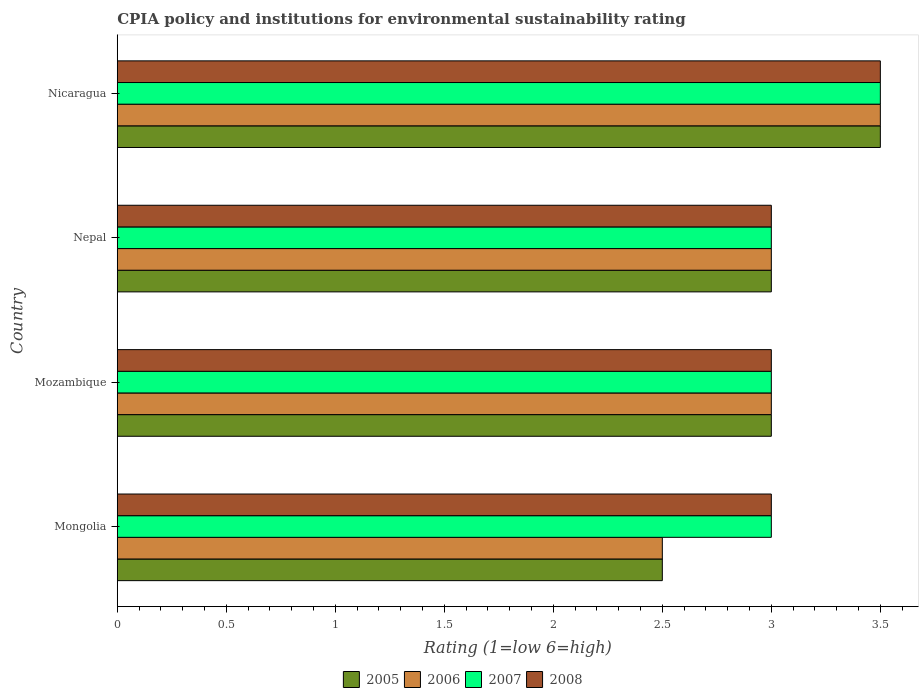How many different coloured bars are there?
Ensure brevity in your answer.  4. Are the number of bars per tick equal to the number of legend labels?
Keep it short and to the point. Yes. How many bars are there on the 3rd tick from the bottom?
Make the answer very short. 4. What is the label of the 2nd group of bars from the top?
Ensure brevity in your answer.  Nepal. In how many cases, is the number of bars for a given country not equal to the number of legend labels?
Provide a short and direct response. 0. What is the CPIA rating in 2007 in Mozambique?
Offer a very short reply. 3. Across all countries, what is the maximum CPIA rating in 2008?
Your response must be concise. 3.5. Across all countries, what is the minimum CPIA rating in 2005?
Your response must be concise. 2.5. In which country was the CPIA rating in 2008 maximum?
Make the answer very short. Nicaragua. In which country was the CPIA rating in 2006 minimum?
Ensure brevity in your answer.  Mongolia. What is the difference between the CPIA rating in 2007 in Mongolia and that in Nepal?
Your response must be concise. 0. What is the average CPIA rating in 2008 per country?
Ensure brevity in your answer.  3.12. What is the difference between the CPIA rating in 2007 and CPIA rating in 2008 in Mongolia?
Offer a very short reply. 0. Is the difference between the CPIA rating in 2007 in Mozambique and Nepal greater than the difference between the CPIA rating in 2008 in Mozambique and Nepal?
Provide a short and direct response. No. What is the difference between the highest and the lowest CPIA rating in 2008?
Make the answer very short. 0.5. In how many countries, is the CPIA rating in 2008 greater than the average CPIA rating in 2008 taken over all countries?
Your answer should be very brief. 1. Is it the case that in every country, the sum of the CPIA rating in 2007 and CPIA rating in 2008 is greater than the sum of CPIA rating in 2006 and CPIA rating in 2005?
Your answer should be compact. No. What does the 2nd bar from the bottom in Mongolia represents?
Make the answer very short. 2006. Is it the case that in every country, the sum of the CPIA rating in 2005 and CPIA rating in 2008 is greater than the CPIA rating in 2007?
Your answer should be very brief. Yes. How many bars are there?
Give a very brief answer. 16. Are the values on the major ticks of X-axis written in scientific E-notation?
Provide a succinct answer. No. Does the graph contain any zero values?
Give a very brief answer. No. Does the graph contain grids?
Your answer should be very brief. No. How are the legend labels stacked?
Offer a very short reply. Horizontal. What is the title of the graph?
Your response must be concise. CPIA policy and institutions for environmental sustainability rating. What is the label or title of the Y-axis?
Provide a succinct answer. Country. What is the Rating (1=low 6=high) of 2005 in Mozambique?
Your answer should be very brief. 3. What is the Rating (1=low 6=high) in 2006 in Mozambique?
Provide a short and direct response. 3. What is the Rating (1=low 6=high) in 2008 in Mozambique?
Your response must be concise. 3. What is the Rating (1=low 6=high) in 2005 in Nepal?
Provide a succinct answer. 3. What is the Rating (1=low 6=high) of 2006 in Nepal?
Your answer should be compact. 3. What is the Rating (1=low 6=high) of 2007 in Nepal?
Make the answer very short. 3. What is the Rating (1=low 6=high) in 2007 in Nicaragua?
Offer a very short reply. 3.5. Across all countries, what is the maximum Rating (1=low 6=high) in 2005?
Offer a terse response. 3.5. Across all countries, what is the maximum Rating (1=low 6=high) in 2006?
Your answer should be compact. 3.5. Across all countries, what is the maximum Rating (1=low 6=high) of 2007?
Offer a very short reply. 3.5. Across all countries, what is the minimum Rating (1=low 6=high) of 2007?
Offer a terse response. 3. What is the total Rating (1=low 6=high) in 2007 in the graph?
Provide a short and direct response. 12.5. What is the difference between the Rating (1=low 6=high) in 2005 in Mongolia and that in Mozambique?
Your answer should be compact. -0.5. What is the difference between the Rating (1=low 6=high) of 2005 in Mongolia and that in Nepal?
Offer a very short reply. -0.5. What is the difference between the Rating (1=low 6=high) in 2008 in Mongolia and that in Nepal?
Your answer should be compact. 0. What is the difference between the Rating (1=low 6=high) of 2005 in Mongolia and that in Nicaragua?
Keep it short and to the point. -1. What is the difference between the Rating (1=low 6=high) of 2006 in Mongolia and that in Nicaragua?
Give a very brief answer. -1. What is the difference between the Rating (1=low 6=high) in 2007 in Mongolia and that in Nicaragua?
Give a very brief answer. -0.5. What is the difference between the Rating (1=low 6=high) in 2008 in Mongolia and that in Nicaragua?
Provide a succinct answer. -0.5. What is the difference between the Rating (1=low 6=high) of 2005 in Mozambique and that in Nepal?
Make the answer very short. 0. What is the difference between the Rating (1=low 6=high) in 2006 in Mozambique and that in Nepal?
Make the answer very short. 0. What is the difference between the Rating (1=low 6=high) in 2007 in Mozambique and that in Nepal?
Your answer should be very brief. 0. What is the difference between the Rating (1=low 6=high) of 2005 in Mozambique and that in Nicaragua?
Ensure brevity in your answer.  -0.5. What is the difference between the Rating (1=low 6=high) of 2008 in Mozambique and that in Nicaragua?
Ensure brevity in your answer.  -0.5. What is the difference between the Rating (1=low 6=high) of 2008 in Nepal and that in Nicaragua?
Provide a short and direct response. -0.5. What is the difference between the Rating (1=low 6=high) in 2005 in Mongolia and the Rating (1=low 6=high) in 2006 in Mozambique?
Keep it short and to the point. -0.5. What is the difference between the Rating (1=low 6=high) in 2005 in Mongolia and the Rating (1=low 6=high) in 2008 in Mozambique?
Your answer should be compact. -0.5. What is the difference between the Rating (1=low 6=high) of 2006 in Mongolia and the Rating (1=low 6=high) of 2008 in Mozambique?
Provide a succinct answer. -0.5. What is the difference between the Rating (1=low 6=high) in 2005 in Mongolia and the Rating (1=low 6=high) in 2008 in Nepal?
Keep it short and to the point. -0.5. What is the difference between the Rating (1=low 6=high) in 2006 in Mongolia and the Rating (1=low 6=high) in 2007 in Nepal?
Offer a very short reply. -0.5. What is the difference between the Rating (1=low 6=high) in 2007 in Mongolia and the Rating (1=low 6=high) in 2008 in Nepal?
Keep it short and to the point. 0. What is the difference between the Rating (1=low 6=high) of 2005 in Mongolia and the Rating (1=low 6=high) of 2006 in Nicaragua?
Give a very brief answer. -1. What is the difference between the Rating (1=low 6=high) in 2005 in Mongolia and the Rating (1=low 6=high) in 2007 in Nicaragua?
Give a very brief answer. -1. What is the difference between the Rating (1=low 6=high) of 2007 in Mongolia and the Rating (1=low 6=high) of 2008 in Nicaragua?
Your answer should be very brief. -0.5. What is the difference between the Rating (1=low 6=high) of 2006 in Mozambique and the Rating (1=low 6=high) of 2008 in Nepal?
Your response must be concise. 0. What is the difference between the Rating (1=low 6=high) of 2005 in Mozambique and the Rating (1=low 6=high) of 2007 in Nicaragua?
Offer a very short reply. -0.5. What is the difference between the Rating (1=low 6=high) of 2005 in Mozambique and the Rating (1=low 6=high) of 2008 in Nicaragua?
Ensure brevity in your answer.  -0.5. What is the difference between the Rating (1=low 6=high) of 2006 in Mozambique and the Rating (1=low 6=high) of 2007 in Nicaragua?
Provide a short and direct response. -0.5. What is the average Rating (1=low 6=high) of 2006 per country?
Provide a short and direct response. 3. What is the average Rating (1=low 6=high) of 2007 per country?
Provide a short and direct response. 3.12. What is the average Rating (1=low 6=high) in 2008 per country?
Make the answer very short. 3.12. What is the difference between the Rating (1=low 6=high) in 2005 and Rating (1=low 6=high) in 2007 in Mongolia?
Your answer should be very brief. -0.5. What is the difference between the Rating (1=low 6=high) in 2005 and Rating (1=low 6=high) in 2008 in Mozambique?
Provide a succinct answer. 0. What is the difference between the Rating (1=low 6=high) in 2006 and Rating (1=low 6=high) in 2007 in Mozambique?
Give a very brief answer. 0. What is the difference between the Rating (1=low 6=high) of 2006 and Rating (1=low 6=high) of 2008 in Mozambique?
Ensure brevity in your answer.  0. What is the difference between the Rating (1=low 6=high) of 2005 and Rating (1=low 6=high) of 2007 in Nepal?
Offer a terse response. 0. What is the difference between the Rating (1=low 6=high) of 2005 and Rating (1=low 6=high) of 2008 in Nepal?
Ensure brevity in your answer.  0. What is the difference between the Rating (1=low 6=high) in 2005 and Rating (1=low 6=high) in 2006 in Nicaragua?
Your answer should be compact. 0. What is the difference between the Rating (1=low 6=high) in 2006 and Rating (1=low 6=high) in 2008 in Nicaragua?
Provide a succinct answer. 0. What is the difference between the Rating (1=low 6=high) of 2007 and Rating (1=low 6=high) of 2008 in Nicaragua?
Keep it short and to the point. 0. What is the ratio of the Rating (1=low 6=high) in 2005 in Mongolia to that in Mozambique?
Offer a terse response. 0.83. What is the ratio of the Rating (1=low 6=high) in 2006 in Mongolia to that in Mozambique?
Provide a succinct answer. 0.83. What is the ratio of the Rating (1=low 6=high) of 2005 in Mongolia to that in Nepal?
Ensure brevity in your answer.  0.83. What is the ratio of the Rating (1=low 6=high) of 2007 in Mongolia to that in Nepal?
Make the answer very short. 1. What is the ratio of the Rating (1=low 6=high) in 2005 in Mongolia to that in Nicaragua?
Ensure brevity in your answer.  0.71. What is the ratio of the Rating (1=low 6=high) in 2008 in Mongolia to that in Nicaragua?
Ensure brevity in your answer.  0.86. What is the ratio of the Rating (1=low 6=high) of 2005 in Mozambique to that in Nepal?
Your answer should be compact. 1. What is the ratio of the Rating (1=low 6=high) of 2006 in Mozambique to that in Nicaragua?
Give a very brief answer. 0.86. What is the ratio of the Rating (1=low 6=high) in 2007 in Mozambique to that in Nicaragua?
Offer a terse response. 0.86. What is the ratio of the Rating (1=low 6=high) in 2005 in Nepal to that in Nicaragua?
Provide a short and direct response. 0.86. What is the ratio of the Rating (1=low 6=high) in 2006 in Nepal to that in Nicaragua?
Your response must be concise. 0.86. What is the ratio of the Rating (1=low 6=high) in 2008 in Nepal to that in Nicaragua?
Make the answer very short. 0.86. What is the difference between the highest and the second highest Rating (1=low 6=high) of 2007?
Make the answer very short. 0.5. What is the difference between the highest and the second highest Rating (1=low 6=high) in 2008?
Ensure brevity in your answer.  0.5. What is the difference between the highest and the lowest Rating (1=low 6=high) of 2005?
Offer a very short reply. 1. What is the difference between the highest and the lowest Rating (1=low 6=high) in 2006?
Your answer should be compact. 1. What is the difference between the highest and the lowest Rating (1=low 6=high) in 2007?
Your answer should be compact. 0.5. What is the difference between the highest and the lowest Rating (1=low 6=high) in 2008?
Make the answer very short. 0.5. 